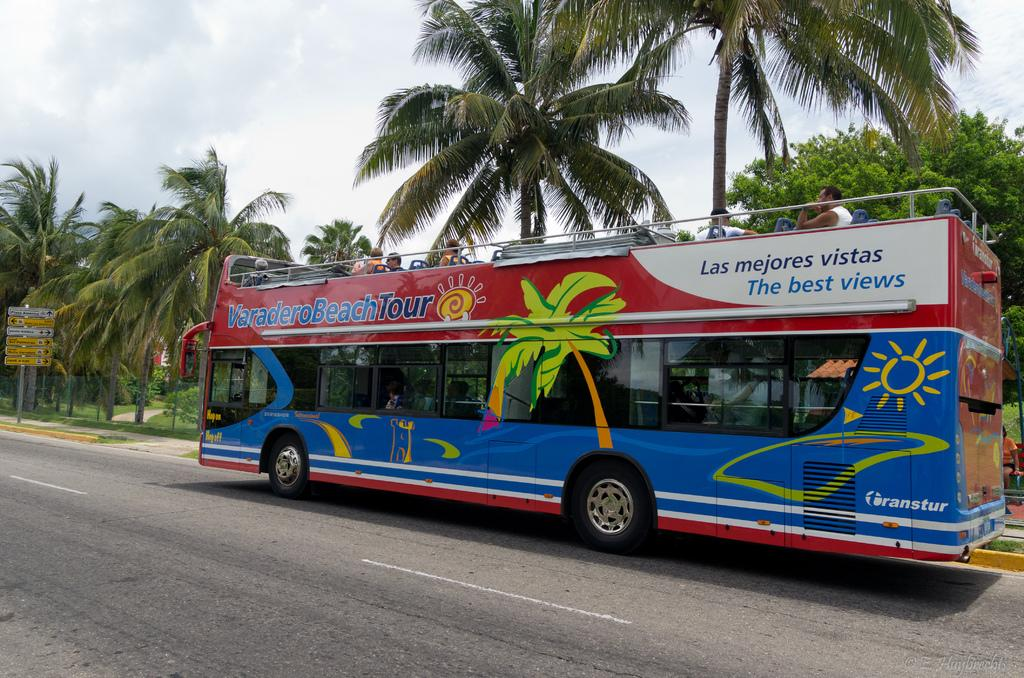Provide a one-sentence caption for the provided image. A double-decker bus gives people the Varadero beach tour. 